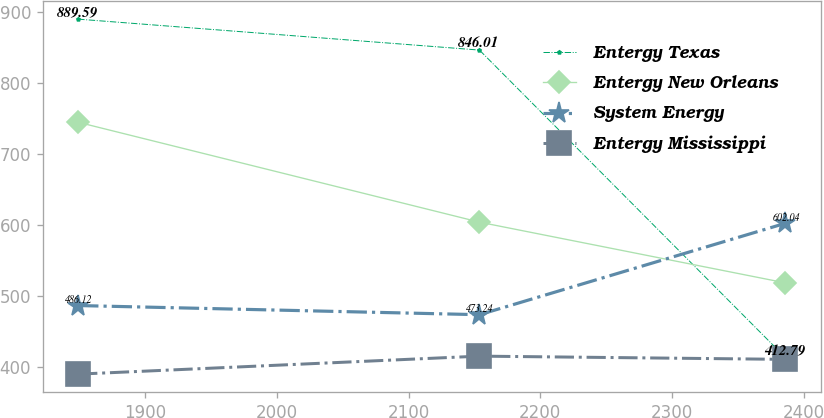<chart> <loc_0><loc_0><loc_500><loc_500><line_chart><ecel><fcel>Entergy Texas<fcel>Entergy New Orleans<fcel>System Energy<fcel>Entergy Mississippi<nl><fcel>1849.12<fcel>889.59<fcel>744.31<fcel>486.12<fcel>389.5<nl><fcel>2153.76<fcel>846.01<fcel>603.61<fcel>473.24<fcel>414.86<nl><fcel>2386.11<fcel>412.79<fcel>518.04<fcel>602.04<fcel>410.31<nl></chart> 